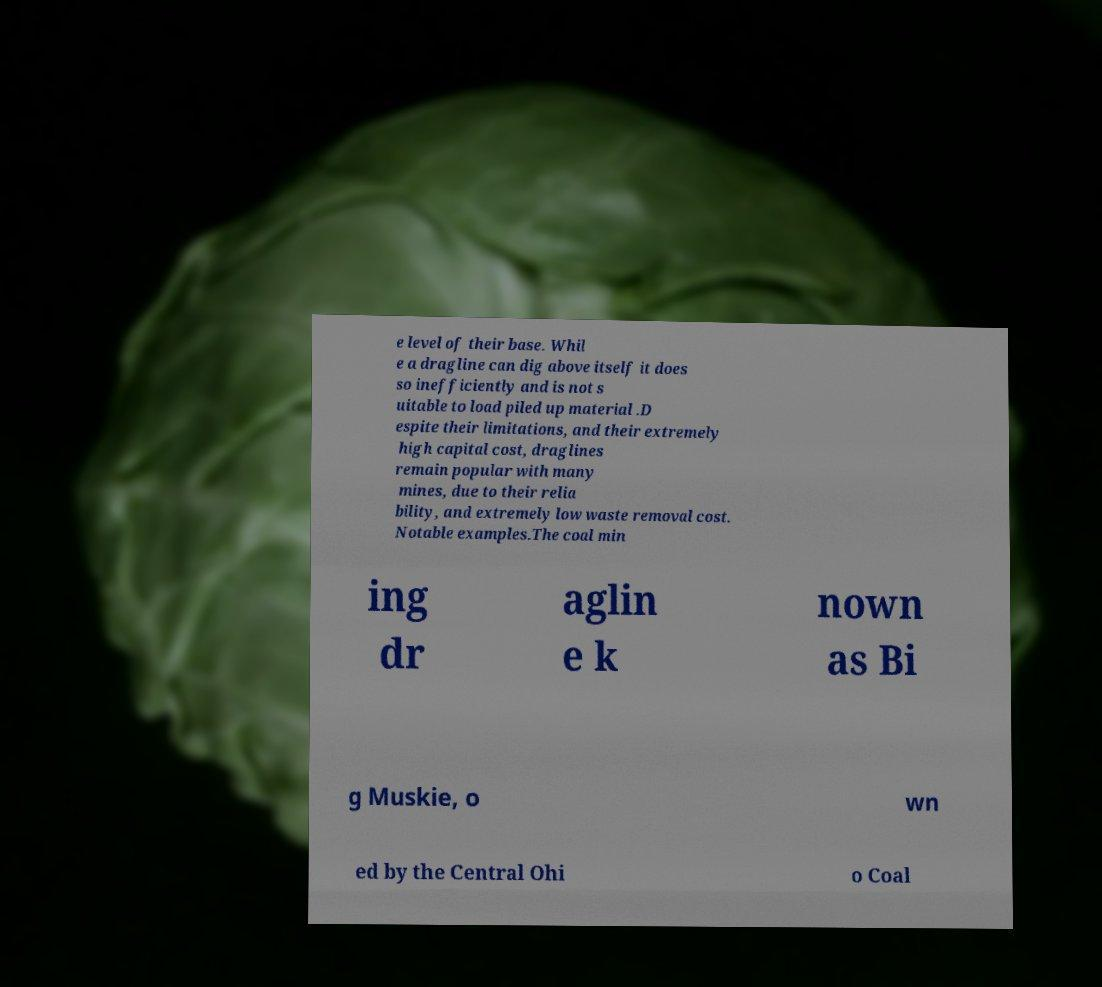What messages or text are displayed in this image? I need them in a readable, typed format. e level of their base. Whil e a dragline can dig above itself it does so inefficiently and is not s uitable to load piled up material .D espite their limitations, and their extremely high capital cost, draglines remain popular with many mines, due to their relia bility, and extremely low waste removal cost. Notable examples.The coal min ing dr aglin e k nown as Bi g Muskie, o wn ed by the Central Ohi o Coal 